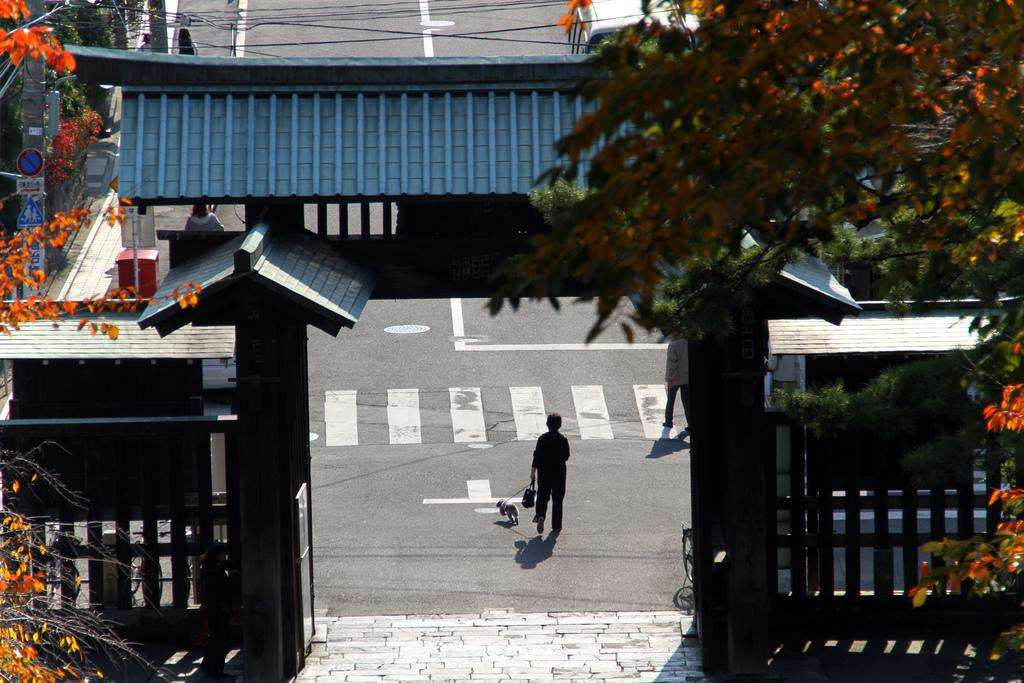What are the people in the image doing? The people in the image are walking on the road. Can you describe what the woman is holding? The woman is holding a bag and a dog. What kind of structure can be seen in the image? There is an arch in the image. What are the signboards used for in the image? The signboards provide information or directions in the image. What is the pole used for in the image? The pole might be used for supporting wires or signs in the image. What type of vegetation is present in the image? Trees are present in the image. What else can be seen in the image that is related to infrastructure? There are wires in the image. What type of dinner is being served in the image? There is no dinner present in the image. What kind of agricultural equipment can be seen in the image? There is no plough or any agricultural equipment present in the image. 